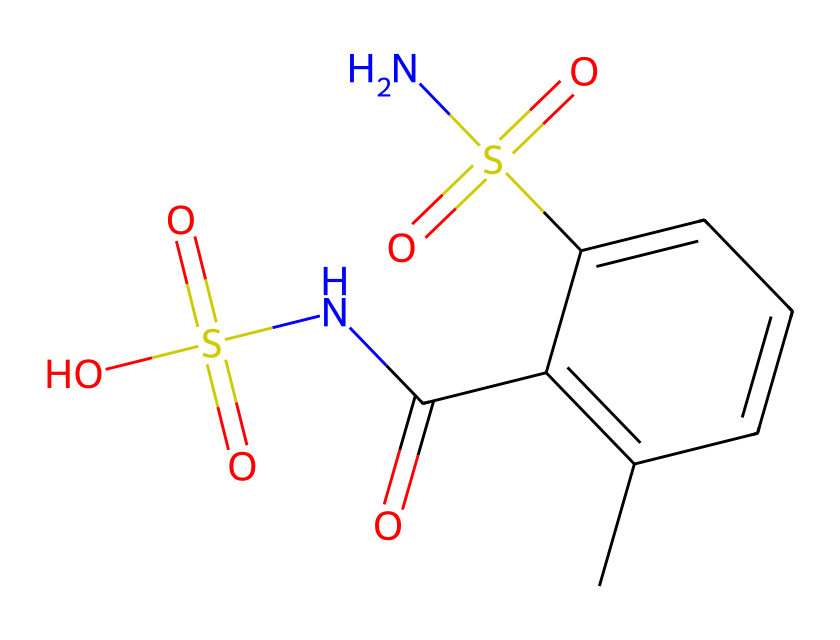What is the molecular formula of this chemical? By analyzing the SMILES representation, we can count the atoms: there are 10 carbon (C), 12 hydrogen (H), 2 nitrogen (N), 1 sulfur (S), and 4 oxygen (O) atoms. Therefore, the molecular formula is C10H12N2O4S.
Answer: C10H12N2O4S How many nitrogen atoms are present in the structure? The structure reveals that there are two nitrogen atoms (N) noted in the SMILES representation.
Answer: 2 What functional groups can be identified in this compound? The presence of a sulfonamide group (due to the N-S bond) and a sulfonic acid group (due to the -SO3H part) can be identified within the chemical structure.
Answer: sulfonamide, sulfonic acid What is the significance of the sulfur atom in this compound? The sulfur atom is crucial as it defines this compound as an organosulfur compound, which often imparts desired properties such as unique colors and stability, particularly in paints.
Answer: unique colors and stability What type of chemical bonding is present between the sulfur and oxygen atoms? The bonding is likely covalent, where the sulfur atom forms strong covalent bonds with oxygen, commonly found in sulfonic acid and sulfonamide structures.
Answer: covalent How many double bonds are present in the structure? The structure contains three double bonds – one between each pair of carbon atoms in the aromatic ring and one between sulfur and oxygen in the sulfonyl group.
Answer: 3 Which part of this chemical contributes to its color in paints? The aromatic ring structure (C=C bonds) and the presence of organosulfur components typically contribute to the vivid colors observed in pigments used in paints.
Answer: aromatic ring 